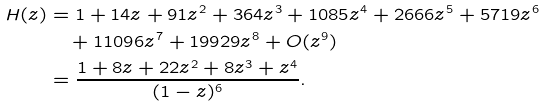<formula> <loc_0><loc_0><loc_500><loc_500>H ( z ) & = 1 + 1 4 z + 9 1 z ^ { 2 } + 3 6 4 z ^ { 3 } + 1 0 8 5 z ^ { 4 } + 2 6 6 6 z ^ { 5 } + 5 7 1 9 z ^ { 6 } \\ & \quad + 1 1 0 9 6 z ^ { 7 } + 1 9 9 2 9 z ^ { 8 } + O ( z ^ { 9 } ) \\ & = \frac { 1 + 8 z + 2 2 z ^ { 2 } + 8 z ^ { 3 } + z ^ { 4 } } { ( 1 - z ) ^ { 6 } } .</formula> 